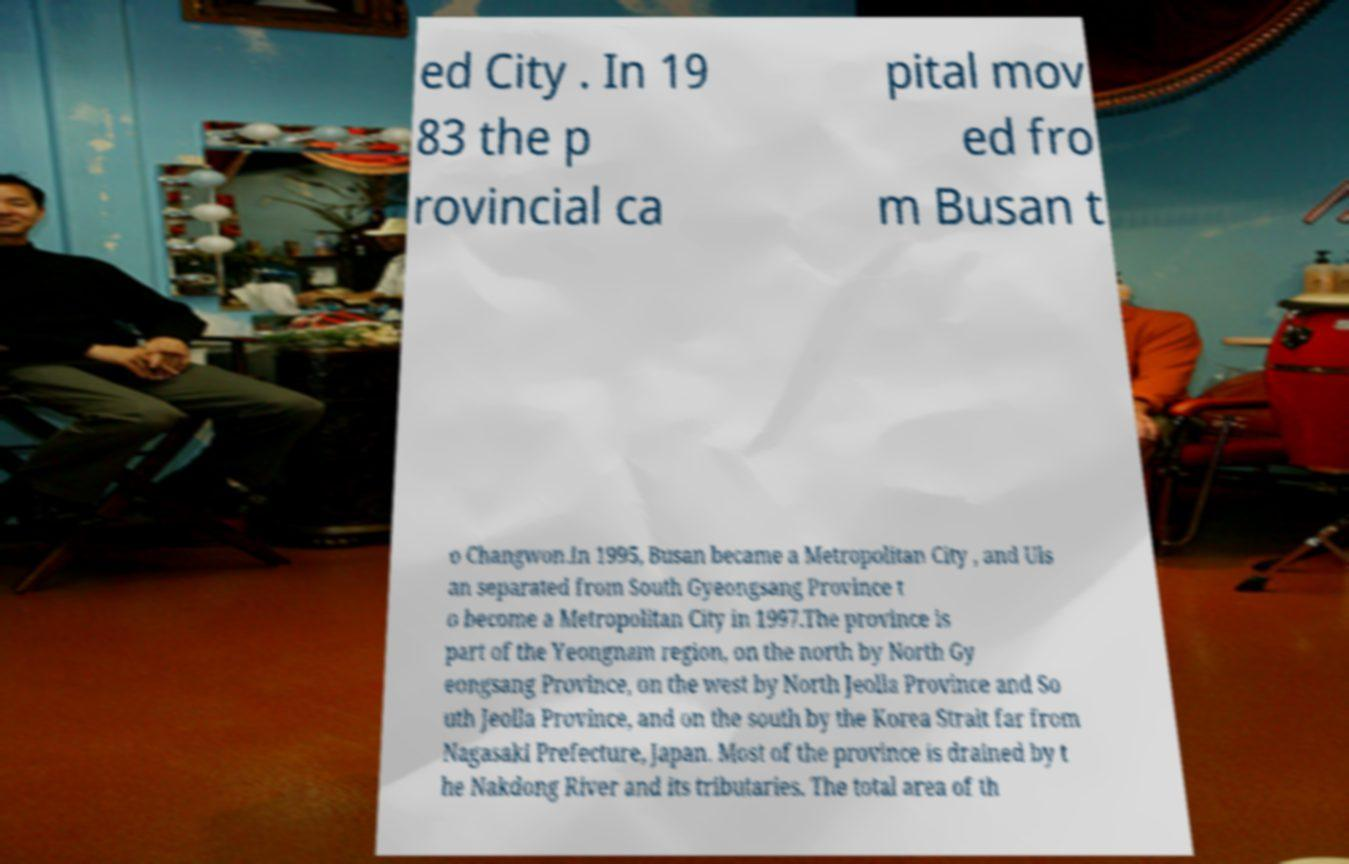Can you accurately transcribe the text from the provided image for me? ed City . In 19 83 the p rovincial ca pital mov ed fro m Busan t o Changwon.In 1995, Busan became a Metropolitan City , and Uls an separated from South Gyeongsang Province t o become a Metropolitan City in 1997.The province is part of the Yeongnam region, on the north by North Gy eongsang Province, on the west by North Jeolla Province and So uth Jeolla Province, and on the south by the Korea Strait far from Nagasaki Prefecture, Japan. Most of the province is drained by t he Nakdong River and its tributaries. The total area of th 